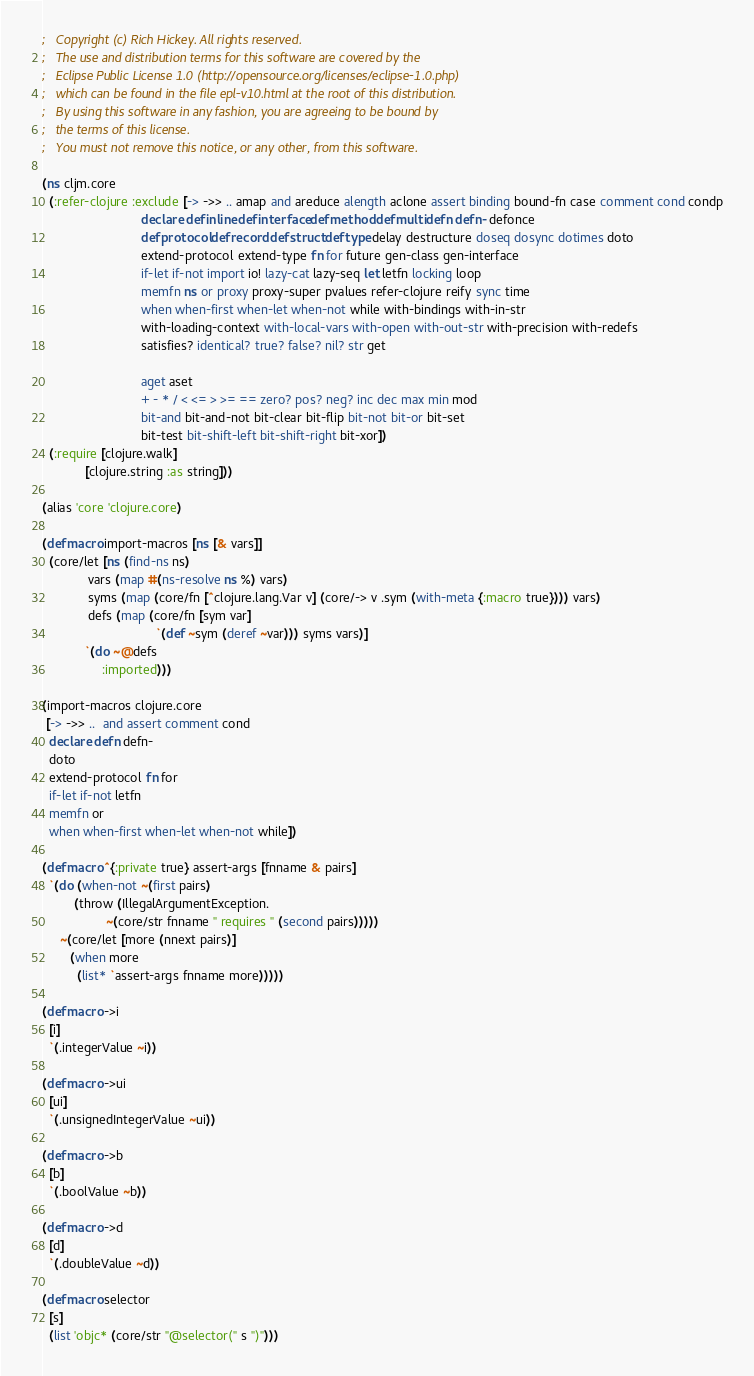Convert code to text. <code><loc_0><loc_0><loc_500><loc_500><_Clojure_>;   Copyright (c) Rich Hickey. All rights reserved.
;   The use and distribution terms for this software are covered by the
;   Eclipse Public License 1.0 (http://opensource.org/licenses/eclipse-1.0.php)
;   which can be found in the file epl-v10.html at the root of this distribution.
;   By using this software in any fashion, you are agreeing to be bound by
;   the terms of this license.
;   You must not remove this notice, or any other, from this software.

(ns cljm.core
  (:refer-clojure :exclude [-> ->> .. amap and areduce alength aclone assert binding bound-fn case comment cond condp
                            declare definline definterface defmethod defmulti defn defn- defonce
                            defprotocol defrecord defstruct deftype delay destructure doseq dosync dotimes doto
                            extend-protocol extend-type fn for future gen-class gen-interface
                            if-let if-not import io! lazy-cat lazy-seq let letfn locking loop
                            memfn ns or proxy proxy-super pvalues refer-clojure reify sync time
                            when when-first when-let when-not while with-bindings with-in-str
                            with-loading-context with-local-vars with-open with-out-str with-precision with-redefs
                            satisfies? identical? true? false? nil? str get

                            aget aset
                            + - * / < <= > >= == zero? pos? neg? inc dec max min mod
                            bit-and bit-and-not bit-clear bit-flip bit-not bit-or bit-set
                            bit-test bit-shift-left bit-shift-right bit-xor])
  (:require [clojure.walk]
            [clojure.string :as string]))

(alias 'core 'clojure.core)

(defmacro import-macros [ns [& vars]]
  (core/let [ns (find-ns ns)
             vars (map #(ns-resolve ns %) vars)
             syms (map (core/fn [^clojure.lang.Var v] (core/-> v .sym (with-meta {:macro true}))) vars)
             defs (map (core/fn [sym var]
                                `(def ~sym (deref ~var))) syms vars)]
            `(do ~@defs
                 :imported)))

(import-macros clojure.core
 [-> ->> ..  and assert comment cond
  declare defn defn-
  doto
  extend-protocol fn for
  if-let if-not letfn
  memfn or
  when when-first when-let when-not while])

(defmacro ^{:private true} assert-args [fnname & pairs]
  `(do (when-not ~(first pairs)
         (throw (IllegalArgumentException.
                  ~(core/str fnname " requires " (second pairs)))))
     ~(core/let [more (nnext pairs)]
        (when more
          (list* `assert-args fnname more)))))

(defmacro ->i
  [i]
  `(.integerValue ~i))

(defmacro ->ui
  [ui]
  `(.unsignedIntegerValue ~ui))

(defmacro ->b
  [b]
  `(.boolValue ~b))

(defmacro ->d
  [d]
  `(.doubleValue ~d))

(defmacro selector
  [s]
  (list 'objc* (core/str "@selector(" s ")")))
</code> 